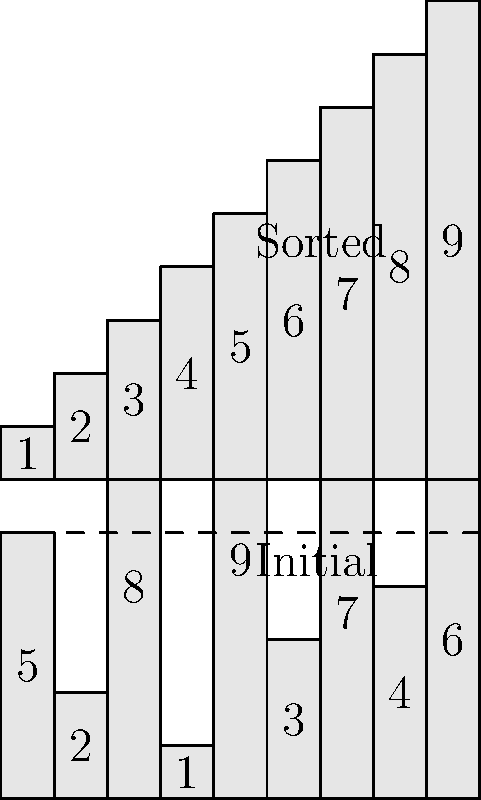In designing a sorting algorithm visualization with step-by-step animation, which key aspect should be prioritized to effectively demonstrate the algorithm's efficiency and functionality? To design an effective sorting algorithm visualization with step-by-step animation, several key aspects should be considered:

1. Visual representation: The initial unsorted array and the final sorted array should be clearly displayed, as shown in the provided graphic.

2. Step-by-step progression: Each step of the sorting process should be visually represented, showing how elements move and compare.

3. Time complexity: The visualization should reflect the algorithm's time complexity, e.g., $O(n^2)$ for bubble sort or $O(n \log n)$ for quicksort.

4. Space complexity: If applicable, the visualization should show how additional memory is used during the sorting process.

5. Comparison and swap operations: Highlight the elements being compared and swapped at each step.

6. Algorithm-specific features: For example, partitioning in quicksort or merging in merge sort should be clearly illustrated.

7. Performance metrics: Display relevant metrics such as the number of comparisons and swaps performed.

8. User interaction: Allow users to control the animation speed or step through the process manually.

9. Color coding: Use colors to distinguish between sorted and unsorted portions of the array, or to highlight elements being compared.

10. Explanatory text: Provide brief explanations of what's happening at each step of the algorithm.

While all these aspects are important, the most critical element for effectively demonstrating the algorithm's efficiency and functionality is the step-by-step progression. This allows viewers to understand how the algorithm works, visualize its efficiency, and grasp its underlying logic.
Answer: Step-by-step progression visualization 